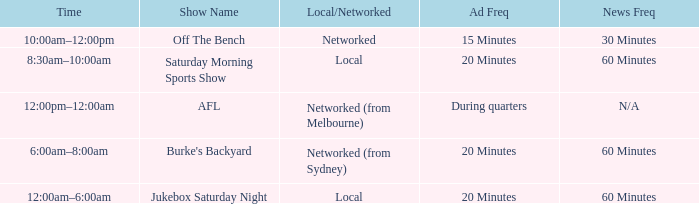What is the local/network with an Ad frequency of 15 minutes? Networked. 